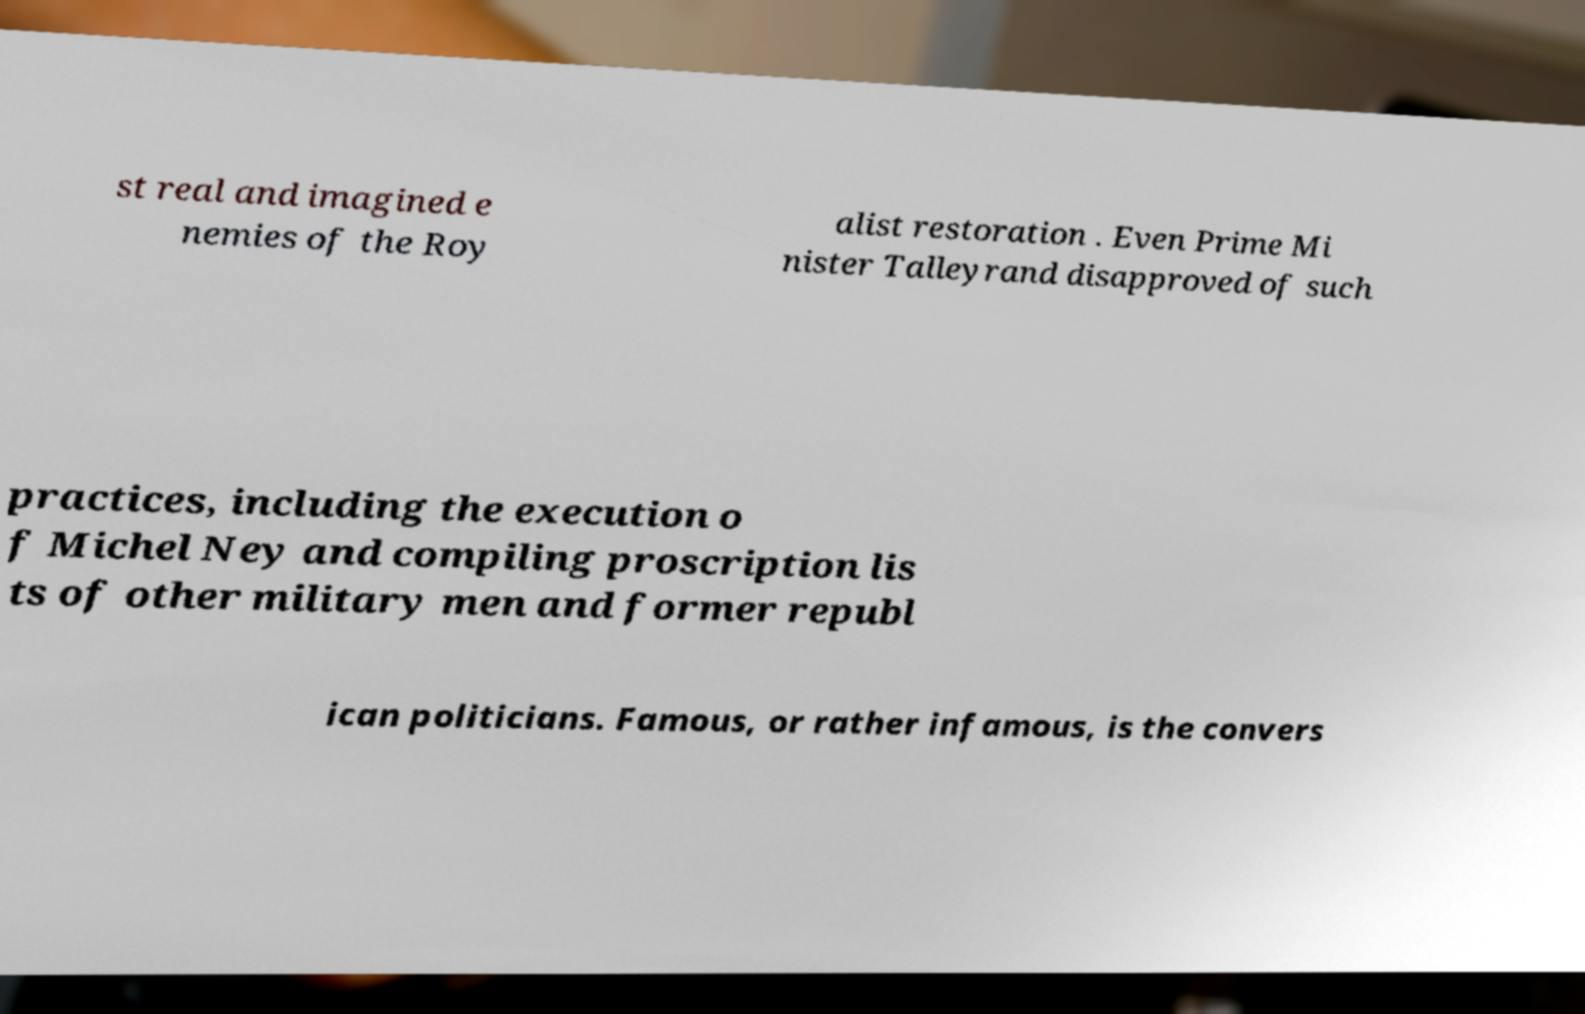Can you read and provide the text displayed in the image?This photo seems to have some interesting text. Can you extract and type it out for me? st real and imagined e nemies of the Roy alist restoration . Even Prime Mi nister Talleyrand disapproved of such practices, including the execution o f Michel Ney and compiling proscription lis ts of other military men and former republ ican politicians. Famous, or rather infamous, is the convers 